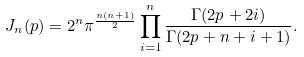Convert formula to latex. <formula><loc_0><loc_0><loc_500><loc_500>J _ { n } ( p ) = 2 ^ { n } \pi ^ { \frac { n ( n + 1 ) } { 2 } } \prod _ { i = 1 } ^ { n } \frac { \Gamma ( 2 p + 2 i ) } { \Gamma ( 2 p + n + i + 1 ) } .</formula> 